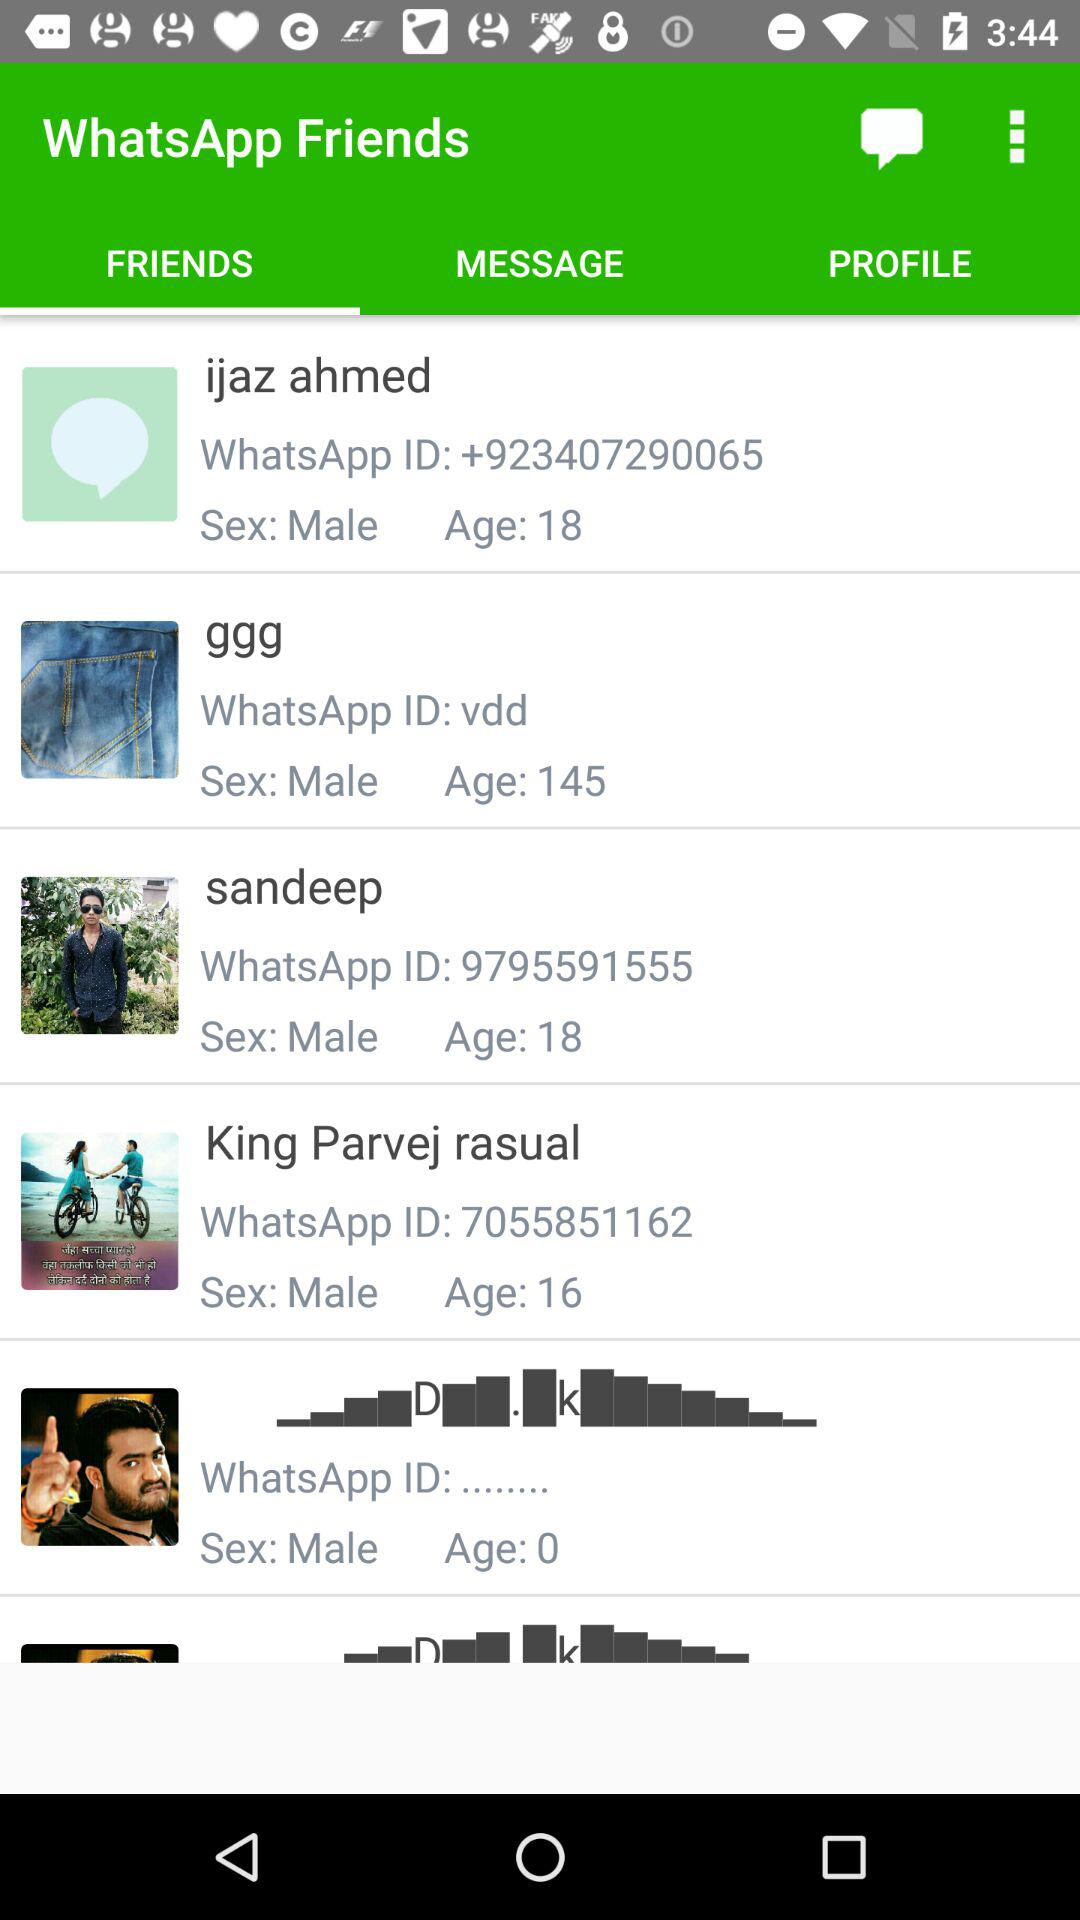Which tab is selected in the "WhatsApp Friends" menu? The selected tab is "FRIENDS". 